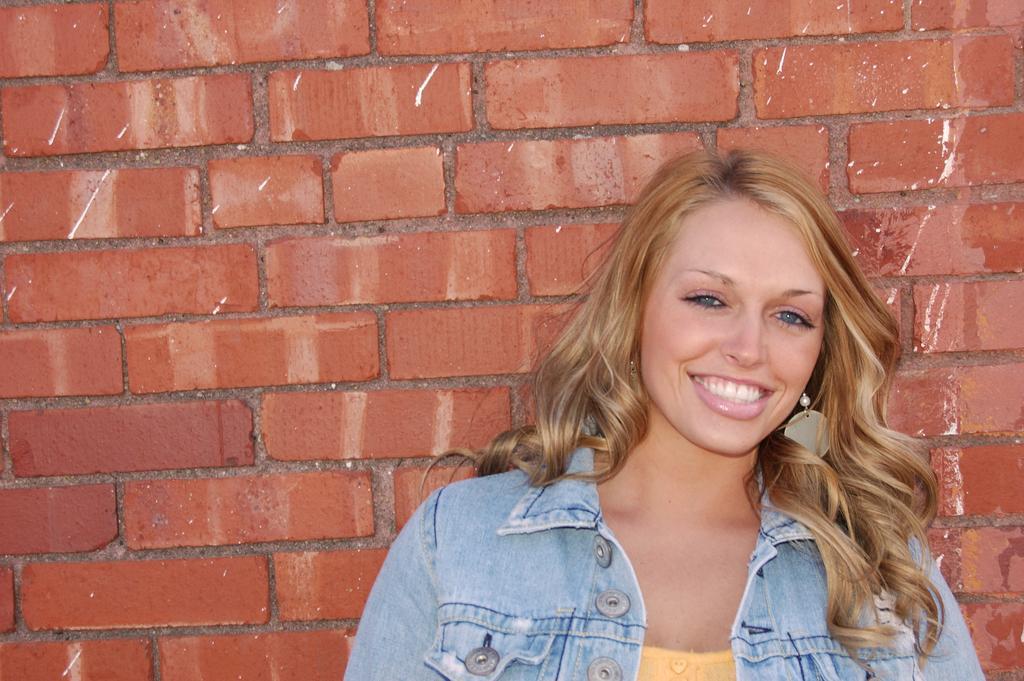In one or two sentences, can you explain what this image depicts? In this picture I can see a woman with a smile on her face and I can see a brick wall in the background. 